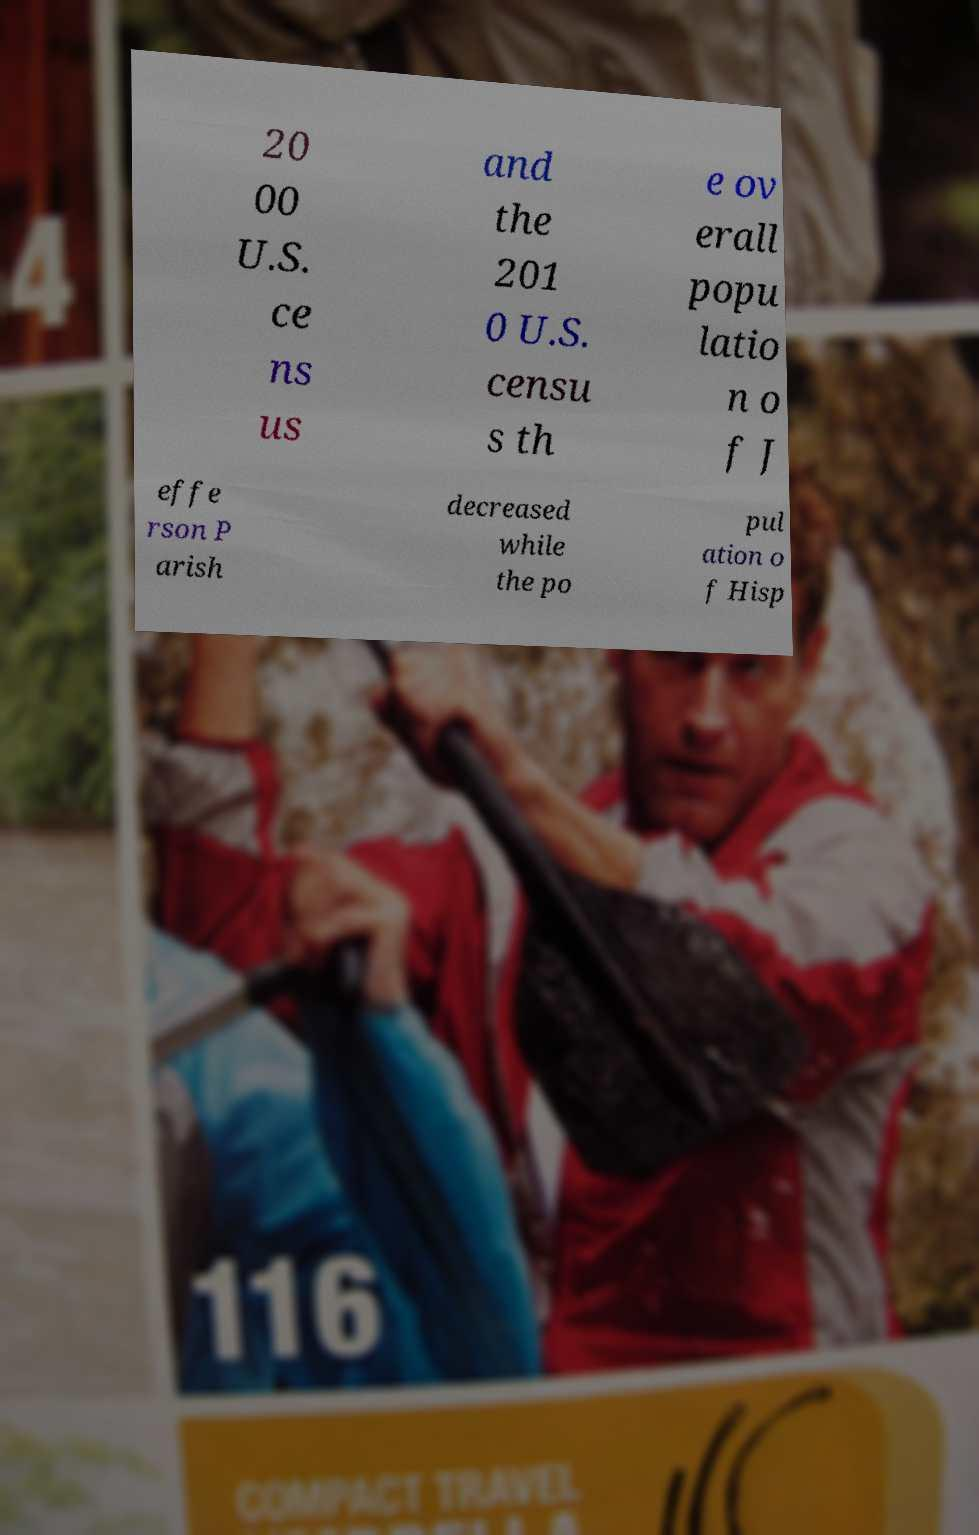Can you accurately transcribe the text from the provided image for me? 20 00 U.S. ce ns us and the 201 0 U.S. censu s th e ov erall popu latio n o f J effe rson P arish decreased while the po pul ation o f Hisp 